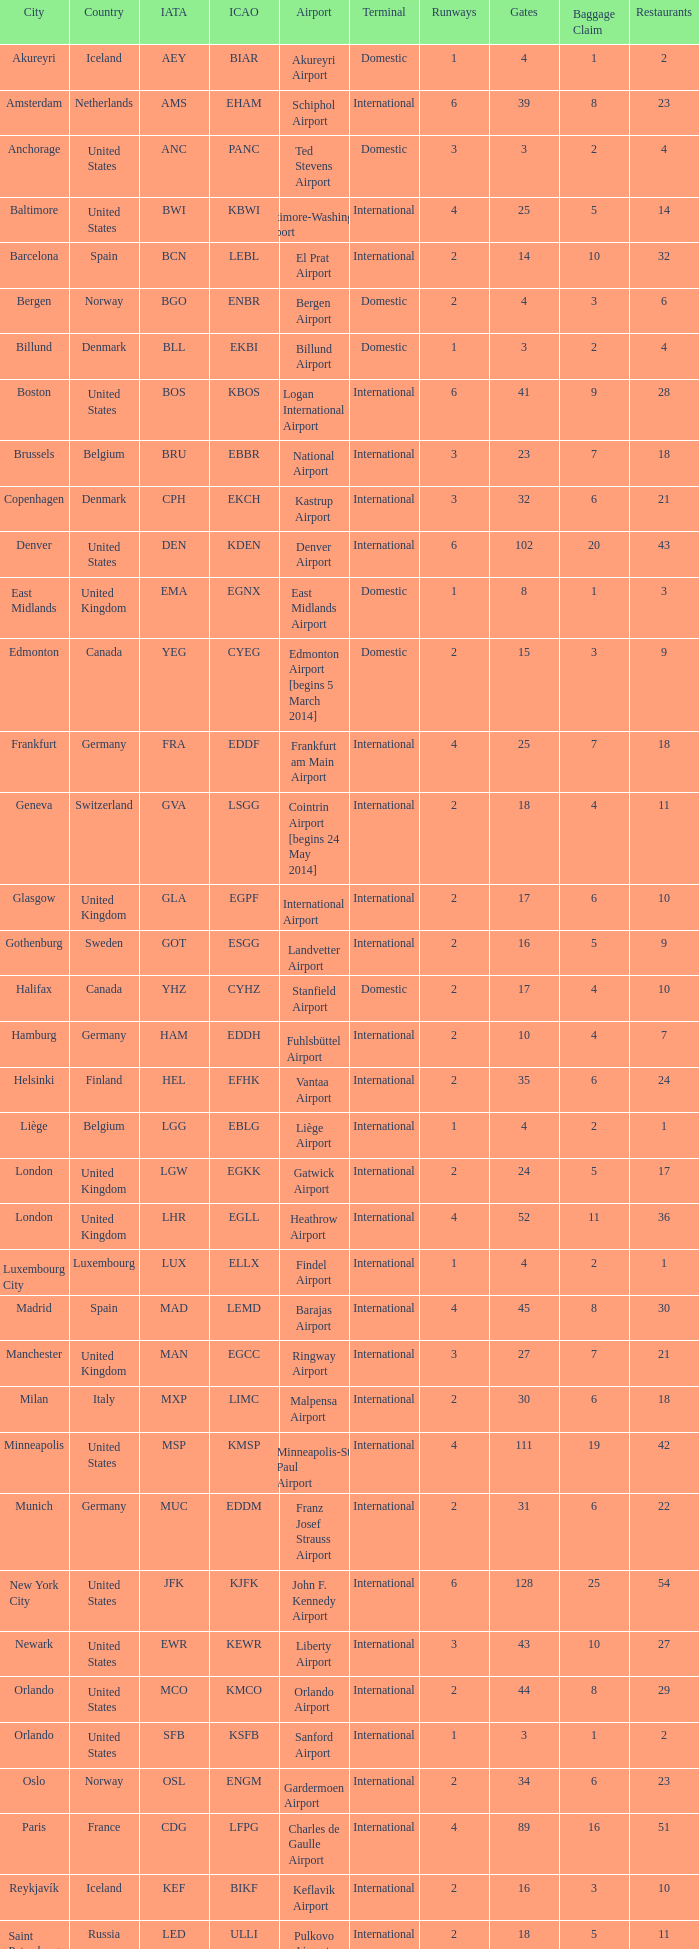What is the IcAO of Frankfurt? EDDF. 